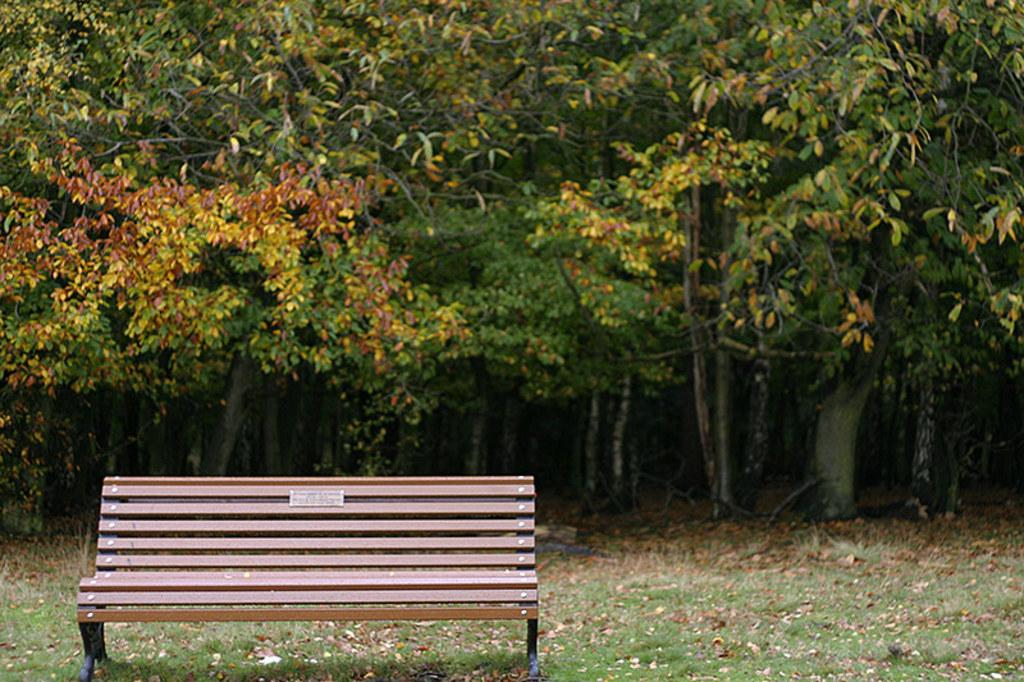What type of seating is located on the left side of the image? There is a bench on the left side of the image. What type of vegetation can be seen in the image? There is grass visible in the image. What is covering the ground in the image? There are dry leaves on the ground. What can be seen in the background of the image? There are trees in the background of the image. What type of thread is being used to sew the linen in the image? There is no thread or linen present in the image; it features a bench, grass, dry leaves, and trees. What part of the brain can be seen in the image? There is no brain visible in the image; it features a bench, grass, dry leaves, and trees. 